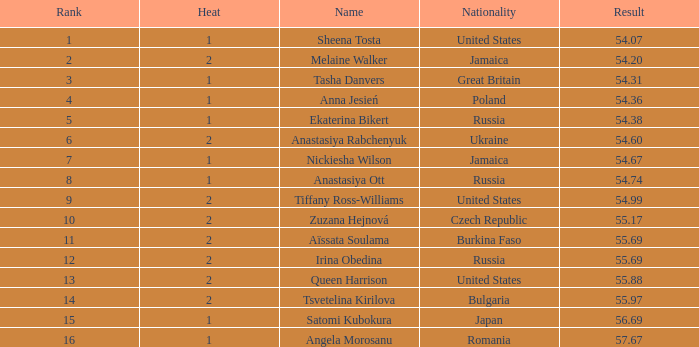Which Heat has a Nationality of bulgaria, and a Result larger than 55.97? None. 